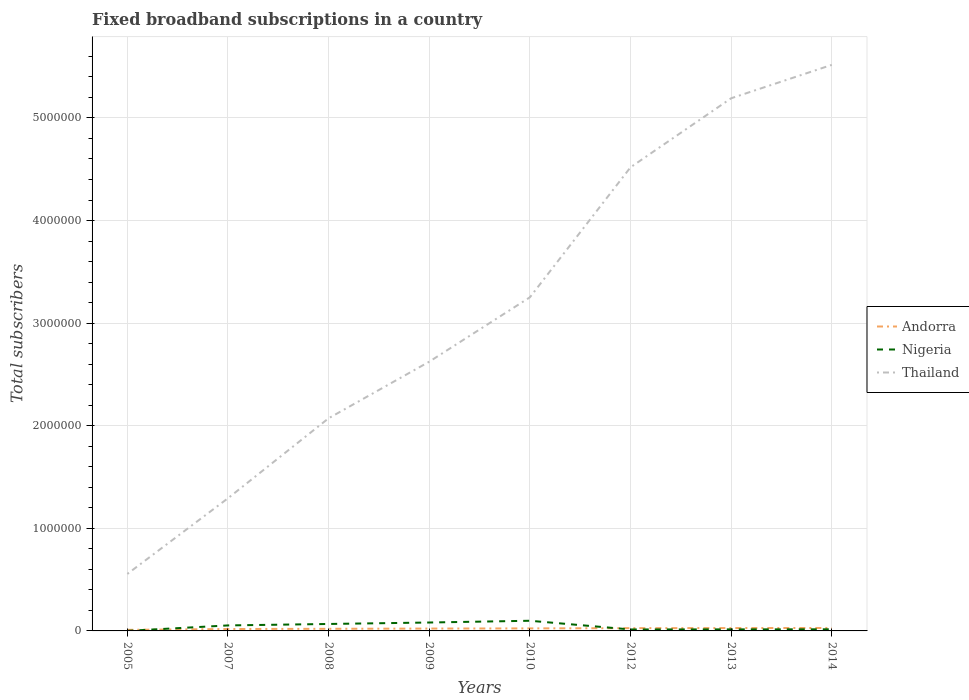Does the line corresponding to Thailand intersect with the line corresponding to Nigeria?
Your answer should be compact. No. Across all years, what is the maximum number of broadband subscriptions in Thailand?
Give a very brief answer. 5.55e+05. In which year was the number of broadband subscriptions in Thailand maximum?
Provide a succinct answer. 2005. What is the total number of broadband subscriptions in Andorra in the graph?
Make the answer very short. -5829. What is the difference between the highest and the second highest number of broadband subscriptions in Andorra?
Provide a succinct answer. 1.84e+04. Is the number of broadband subscriptions in Thailand strictly greater than the number of broadband subscriptions in Andorra over the years?
Give a very brief answer. No. What is the difference between two consecutive major ticks on the Y-axis?
Give a very brief answer. 1.00e+06. Where does the legend appear in the graph?
Ensure brevity in your answer.  Center right. How many legend labels are there?
Your answer should be compact. 3. How are the legend labels stacked?
Your answer should be very brief. Vertical. What is the title of the graph?
Provide a succinct answer. Fixed broadband subscriptions in a country. What is the label or title of the X-axis?
Give a very brief answer. Years. What is the label or title of the Y-axis?
Offer a terse response. Total subscribers. What is the Total subscribers in Andorra in 2005?
Provide a short and direct response. 1.03e+04. What is the Total subscribers in Thailand in 2005?
Give a very brief answer. 5.55e+05. What is the Total subscribers in Andorra in 2007?
Make the answer very short. 1.85e+04. What is the Total subscribers in Nigeria in 2007?
Your answer should be very brief. 5.36e+04. What is the Total subscribers of Thailand in 2007?
Your response must be concise. 1.29e+06. What is the Total subscribers of Andorra in 2008?
Offer a terse response. 2.07e+04. What is the Total subscribers of Nigeria in 2008?
Offer a terse response. 6.78e+04. What is the Total subscribers in Thailand in 2008?
Provide a short and direct response. 2.07e+06. What is the Total subscribers in Andorra in 2009?
Give a very brief answer. 2.29e+04. What is the Total subscribers in Nigeria in 2009?
Offer a terse response. 8.20e+04. What is the Total subscribers of Thailand in 2009?
Provide a short and direct response. 2.62e+06. What is the Total subscribers in Andorra in 2010?
Your response must be concise. 2.45e+04. What is the Total subscribers in Nigeria in 2010?
Provide a short and direct response. 9.91e+04. What is the Total subscribers of Thailand in 2010?
Your answer should be very brief. 3.25e+06. What is the Total subscribers of Andorra in 2012?
Offer a very short reply. 2.69e+04. What is the Total subscribers in Nigeria in 2012?
Offer a very short reply. 1.43e+04. What is the Total subscribers of Thailand in 2012?
Your response must be concise. 4.52e+06. What is the Total subscribers in Andorra in 2013?
Give a very brief answer. 2.77e+04. What is the Total subscribers in Nigeria in 2013?
Your answer should be very brief. 1.50e+04. What is the Total subscribers in Thailand in 2013?
Provide a succinct answer. 5.19e+06. What is the Total subscribers of Andorra in 2014?
Your answer should be very brief. 2.88e+04. What is the Total subscribers of Nigeria in 2014?
Make the answer very short. 1.57e+04. What is the Total subscribers of Thailand in 2014?
Provide a short and direct response. 5.52e+06. Across all years, what is the maximum Total subscribers in Andorra?
Give a very brief answer. 2.88e+04. Across all years, what is the maximum Total subscribers in Nigeria?
Give a very brief answer. 9.91e+04. Across all years, what is the maximum Total subscribers in Thailand?
Offer a very short reply. 5.52e+06. Across all years, what is the minimum Total subscribers of Andorra?
Your answer should be very brief. 1.03e+04. Across all years, what is the minimum Total subscribers in Nigeria?
Keep it short and to the point. 500. Across all years, what is the minimum Total subscribers of Thailand?
Your answer should be very brief. 5.55e+05. What is the total Total subscribers of Andorra in the graph?
Give a very brief answer. 1.80e+05. What is the total Total subscribers in Nigeria in the graph?
Give a very brief answer. 3.48e+05. What is the total Total subscribers of Thailand in the graph?
Offer a terse response. 2.50e+07. What is the difference between the Total subscribers of Andorra in 2005 and that in 2007?
Offer a very short reply. -8185. What is the difference between the Total subscribers in Nigeria in 2005 and that in 2007?
Make the answer very short. -5.31e+04. What is the difference between the Total subscribers in Thailand in 2005 and that in 2007?
Ensure brevity in your answer.  -7.38e+05. What is the difference between the Total subscribers of Andorra in 2005 and that in 2008?
Give a very brief answer. -1.03e+04. What is the difference between the Total subscribers in Nigeria in 2005 and that in 2008?
Make the answer very short. -6.73e+04. What is the difference between the Total subscribers of Thailand in 2005 and that in 2008?
Give a very brief answer. -1.52e+06. What is the difference between the Total subscribers of Andorra in 2005 and that in 2009?
Offer a very short reply. -1.26e+04. What is the difference between the Total subscribers of Nigeria in 2005 and that in 2009?
Ensure brevity in your answer.  -8.15e+04. What is the difference between the Total subscribers of Thailand in 2005 and that in 2009?
Offer a very short reply. -2.07e+06. What is the difference between the Total subscribers of Andorra in 2005 and that in 2010?
Offer a very short reply. -1.42e+04. What is the difference between the Total subscribers of Nigeria in 2005 and that in 2010?
Provide a succinct answer. -9.86e+04. What is the difference between the Total subscribers in Thailand in 2005 and that in 2010?
Make the answer very short. -2.70e+06. What is the difference between the Total subscribers in Andorra in 2005 and that in 2012?
Give a very brief answer. -1.66e+04. What is the difference between the Total subscribers of Nigeria in 2005 and that in 2012?
Your answer should be compact. -1.38e+04. What is the difference between the Total subscribers of Thailand in 2005 and that in 2012?
Provide a short and direct response. -3.96e+06. What is the difference between the Total subscribers of Andorra in 2005 and that in 2013?
Give a very brief answer. -1.74e+04. What is the difference between the Total subscribers in Nigeria in 2005 and that in 2013?
Your answer should be compact. -1.45e+04. What is the difference between the Total subscribers in Thailand in 2005 and that in 2013?
Offer a terse response. -4.64e+06. What is the difference between the Total subscribers of Andorra in 2005 and that in 2014?
Your answer should be very brief. -1.84e+04. What is the difference between the Total subscribers in Nigeria in 2005 and that in 2014?
Keep it short and to the point. -1.52e+04. What is the difference between the Total subscribers in Thailand in 2005 and that in 2014?
Offer a terse response. -4.96e+06. What is the difference between the Total subscribers of Andorra in 2007 and that in 2008?
Offer a terse response. -2146. What is the difference between the Total subscribers of Nigeria in 2007 and that in 2008?
Your answer should be very brief. -1.42e+04. What is the difference between the Total subscribers in Thailand in 2007 and that in 2008?
Offer a very short reply. -7.79e+05. What is the difference between the Total subscribers of Andorra in 2007 and that in 2009?
Your answer should be very brief. -4415. What is the difference between the Total subscribers in Nigeria in 2007 and that in 2009?
Provide a succinct answer. -2.84e+04. What is the difference between the Total subscribers in Thailand in 2007 and that in 2009?
Your answer should be very brief. -1.33e+06. What is the difference between the Total subscribers of Andorra in 2007 and that in 2010?
Offer a terse response. -5976. What is the difference between the Total subscribers of Nigeria in 2007 and that in 2010?
Provide a succinct answer. -4.55e+04. What is the difference between the Total subscribers of Thailand in 2007 and that in 2010?
Make the answer very short. -1.96e+06. What is the difference between the Total subscribers of Andorra in 2007 and that in 2012?
Keep it short and to the point. -8379. What is the difference between the Total subscribers of Nigeria in 2007 and that in 2012?
Your answer should be very brief. 3.93e+04. What is the difference between the Total subscribers in Thailand in 2007 and that in 2012?
Keep it short and to the point. -3.23e+06. What is the difference between the Total subscribers of Andorra in 2007 and that in 2013?
Make the answer very short. -9208. What is the difference between the Total subscribers of Nigeria in 2007 and that in 2013?
Offer a very short reply. 3.85e+04. What is the difference between the Total subscribers in Thailand in 2007 and that in 2013?
Your response must be concise. -3.90e+06. What is the difference between the Total subscribers in Andorra in 2007 and that in 2014?
Make the answer very short. -1.02e+04. What is the difference between the Total subscribers of Nigeria in 2007 and that in 2014?
Provide a succinct answer. 3.79e+04. What is the difference between the Total subscribers in Thailand in 2007 and that in 2014?
Ensure brevity in your answer.  -4.22e+06. What is the difference between the Total subscribers in Andorra in 2008 and that in 2009?
Your response must be concise. -2269. What is the difference between the Total subscribers in Nigeria in 2008 and that in 2009?
Offer a terse response. -1.42e+04. What is the difference between the Total subscribers of Thailand in 2008 and that in 2009?
Your response must be concise. -5.51e+05. What is the difference between the Total subscribers of Andorra in 2008 and that in 2010?
Keep it short and to the point. -3830. What is the difference between the Total subscribers in Nigeria in 2008 and that in 2010?
Ensure brevity in your answer.  -3.13e+04. What is the difference between the Total subscribers in Thailand in 2008 and that in 2010?
Your response must be concise. -1.18e+06. What is the difference between the Total subscribers in Andorra in 2008 and that in 2012?
Offer a very short reply. -6233. What is the difference between the Total subscribers in Nigeria in 2008 and that in 2012?
Give a very brief answer. 5.35e+04. What is the difference between the Total subscribers of Thailand in 2008 and that in 2012?
Offer a terse response. -2.45e+06. What is the difference between the Total subscribers in Andorra in 2008 and that in 2013?
Your response must be concise. -7062. What is the difference between the Total subscribers in Nigeria in 2008 and that in 2013?
Your response must be concise. 5.27e+04. What is the difference between the Total subscribers of Thailand in 2008 and that in 2013?
Give a very brief answer. -3.12e+06. What is the difference between the Total subscribers of Andorra in 2008 and that in 2014?
Keep it short and to the point. -8098. What is the difference between the Total subscribers in Nigeria in 2008 and that in 2014?
Your response must be concise. 5.20e+04. What is the difference between the Total subscribers of Thailand in 2008 and that in 2014?
Make the answer very short. -3.44e+06. What is the difference between the Total subscribers in Andorra in 2009 and that in 2010?
Your answer should be compact. -1561. What is the difference between the Total subscribers of Nigeria in 2009 and that in 2010?
Keep it short and to the point. -1.72e+04. What is the difference between the Total subscribers of Thailand in 2009 and that in 2010?
Ensure brevity in your answer.  -6.28e+05. What is the difference between the Total subscribers of Andorra in 2009 and that in 2012?
Keep it short and to the point. -3964. What is the difference between the Total subscribers of Nigeria in 2009 and that in 2012?
Your answer should be compact. 6.77e+04. What is the difference between the Total subscribers in Thailand in 2009 and that in 2012?
Give a very brief answer. -1.89e+06. What is the difference between the Total subscribers in Andorra in 2009 and that in 2013?
Offer a very short reply. -4793. What is the difference between the Total subscribers in Nigeria in 2009 and that in 2013?
Your answer should be very brief. 6.69e+04. What is the difference between the Total subscribers of Thailand in 2009 and that in 2013?
Provide a succinct answer. -2.57e+06. What is the difference between the Total subscribers of Andorra in 2009 and that in 2014?
Give a very brief answer. -5829. What is the difference between the Total subscribers in Nigeria in 2009 and that in 2014?
Make the answer very short. 6.62e+04. What is the difference between the Total subscribers in Thailand in 2009 and that in 2014?
Your answer should be very brief. -2.89e+06. What is the difference between the Total subscribers in Andorra in 2010 and that in 2012?
Your answer should be very brief. -2403. What is the difference between the Total subscribers of Nigeria in 2010 and that in 2012?
Your answer should be compact. 8.48e+04. What is the difference between the Total subscribers of Thailand in 2010 and that in 2012?
Your answer should be very brief. -1.27e+06. What is the difference between the Total subscribers of Andorra in 2010 and that in 2013?
Provide a succinct answer. -3232. What is the difference between the Total subscribers of Nigeria in 2010 and that in 2013?
Offer a terse response. 8.41e+04. What is the difference between the Total subscribers in Thailand in 2010 and that in 2013?
Provide a succinct answer. -1.94e+06. What is the difference between the Total subscribers in Andorra in 2010 and that in 2014?
Ensure brevity in your answer.  -4268. What is the difference between the Total subscribers in Nigeria in 2010 and that in 2014?
Offer a terse response. 8.34e+04. What is the difference between the Total subscribers of Thailand in 2010 and that in 2014?
Keep it short and to the point. -2.27e+06. What is the difference between the Total subscribers of Andorra in 2012 and that in 2013?
Your response must be concise. -829. What is the difference between the Total subscribers in Nigeria in 2012 and that in 2013?
Keep it short and to the point. -766. What is the difference between the Total subscribers in Thailand in 2012 and that in 2013?
Give a very brief answer. -6.73e+05. What is the difference between the Total subscribers of Andorra in 2012 and that in 2014?
Your response must be concise. -1865. What is the difference between the Total subscribers of Nigeria in 2012 and that in 2014?
Offer a terse response. -1461. What is the difference between the Total subscribers of Thailand in 2012 and that in 2014?
Your response must be concise. -9.98e+05. What is the difference between the Total subscribers of Andorra in 2013 and that in 2014?
Your response must be concise. -1036. What is the difference between the Total subscribers in Nigeria in 2013 and that in 2014?
Provide a succinct answer. -695. What is the difference between the Total subscribers of Thailand in 2013 and that in 2014?
Your response must be concise. -3.25e+05. What is the difference between the Total subscribers in Andorra in 2005 and the Total subscribers in Nigeria in 2007?
Your answer should be very brief. -4.33e+04. What is the difference between the Total subscribers of Andorra in 2005 and the Total subscribers of Thailand in 2007?
Provide a succinct answer. -1.28e+06. What is the difference between the Total subscribers of Nigeria in 2005 and the Total subscribers of Thailand in 2007?
Your answer should be compact. -1.29e+06. What is the difference between the Total subscribers in Andorra in 2005 and the Total subscribers in Nigeria in 2008?
Your answer should be very brief. -5.74e+04. What is the difference between the Total subscribers of Andorra in 2005 and the Total subscribers of Thailand in 2008?
Your answer should be very brief. -2.06e+06. What is the difference between the Total subscribers in Nigeria in 2005 and the Total subscribers in Thailand in 2008?
Give a very brief answer. -2.07e+06. What is the difference between the Total subscribers of Andorra in 2005 and the Total subscribers of Nigeria in 2009?
Offer a terse response. -7.16e+04. What is the difference between the Total subscribers of Andorra in 2005 and the Total subscribers of Thailand in 2009?
Offer a terse response. -2.61e+06. What is the difference between the Total subscribers of Nigeria in 2005 and the Total subscribers of Thailand in 2009?
Your answer should be very brief. -2.62e+06. What is the difference between the Total subscribers of Andorra in 2005 and the Total subscribers of Nigeria in 2010?
Give a very brief answer. -8.88e+04. What is the difference between the Total subscribers of Andorra in 2005 and the Total subscribers of Thailand in 2010?
Offer a very short reply. -3.24e+06. What is the difference between the Total subscribers in Nigeria in 2005 and the Total subscribers in Thailand in 2010?
Offer a very short reply. -3.25e+06. What is the difference between the Total subscribers in Andorra in 2005 and the Total subscribers in Nigeria in 2012?
Give a very brief answer. -3938. What is the difference between the Total subscribers of Andorra in 2005 and the Total subscribers of Thailand in 2012?
Offer a very short reply. -4.51e+06. What is the difference between the Total subscribers in Nigeria in 2005 and the Total subscribers in Thailand in 2012?
Your answer should be compact. -4.52e+06. What is the difference between the Total subscribers of Andorra in 2005 and the Total subscribers of Nigeria in 2013?
Your answer should be compact. -4704. What is the difference between the Total subscribers of Andorra in 2005 and the Total subscribers of Thailand in 2013?
Keep it short and to the point. -5.18e+06. What is the difference between the Total subscribers in Nigeria in 2005 and the Total subscribers in Thailand in 2013?
Your response must be concise. -5.19e+06. What is the difference between the Total subscribers in Andorra in 2005 and the Total subscribers in Nigeria in 2014?
Keep it short and to the point. -5399. What is the difference between the Total subscribers of Andorra in 2005 and the Total subscribers of Thailand in 2014?
Offer a terse response. -5.51e+06. What is the difference between the Total subscribers in Nigeria in 2005 and the Total subscribers in Thailand in 2014?
Your answer should be very brief. -5.52e+06. What is the difference between the Total subscribers in Andorra in 2007 and the Total subscribers in Nigeria in 2008?
Provide a short and direct response. -4.92e+04. What is the difference between the Total subscribers in Andorra in 2007 and the Total subscribers in Thailand in 2008?
Your answer should be very brief. -2.05e+06. What is the difference between the Total subscribers in Nigeria in 2007 and the Total subscribers in Thailand in 2008?
Make the answer very short. -2.02e+06. What is the difference between the Total subscribers of Andorra in 2007 and the Total subscribers of Nigeria in 2009?
Your response must be concise. -6.34e+04. What is the difference between the Total subscribers in Andorra in 2007 and the Total subscribers in Thailand in 2009?
Make the answer very short. -2.61e+06. What is the difference between the Total subscribers in Nigeria in 2007 and the Total subscribers in Thailand in 2009?
Provide a succinct answer. -2.57e+06. What is the difference between the Total subscribers of Andorra in 2007 and the Total subscribers of Nigeria in 2010?
Offer a very short reply. -8.06e+04. What is the difference between the Total subscribers in Andorra in 2007 and the Total subscribers in Thailand in 2010?
Your answer should be compact. -3.23e+06. What is the difference between the Total subscribers of Nigeria in 2007 and the Total subscribers of Thailand in 2010?
Your answer should be compact. -3.20e+06. What is the difference between the Total subscribers in Andorra in 2007 and the Total subscribers in Nigeria in 2012?
Offer a very short reply. 4247. What is the difference between the Total subscribers in Andorra in 2007 and the Total subscribers in Thailand in 2012?
Your answer should be compact. -4.50e+06. What is the difference between the Total subscribers of Nigeria in 2007 and the Total subscribers of Thailand in 2012?
Provide a succinct answer. -4.47e+06. What is the difference between the Total subscribers of Andorra in 2007 and the Total subscribers of Nigeria in 2013?
Keep it short and to the point. 3481. What is the difference between the Total subscribers of Andorra in 2007 and the Total subscribers of Thailand in 2013?
Offer a terse response. -5.17e+06. What is the difference between the Total subscribers of Nigeria in 2007 and the Total subscribers of Thailand in 2013?
Provide a succinct answer. -5.14e+06. What is the difference between the Total subscribers in Andorra in 2007 and the Total subscribers in Nigeria in 2014?
Your answer should be compact. 2786. What is the difference between the Total subscribers in Andorra in 2007 and the Total subscribers in Thailand in 2014?
Offer a terse response. -5.50e+06. What is the difference between the Total subscribers in Nigeria in 2007 and the Total subscribers in Thailand in 2014?
Ensure brevity in your answer.  -5.46e+06. What is the difference between the Total subscribers of Andorra in 2008 and the Total subscribers of Nigeria in 2009?
Offer a terse response. -6.13e+04. What is the difference between the Total subscribers of Andorra in 2008 and the Total subscribers of Thailand in 2009?
Offer a very short reply. -2.60e+06. What is the difference between the Total subscribers in Nigeria in 2008 and the Total subscribers in Thailand in 2009?
Offer a very short reply. -2.56e+06. What is the difference between the Total subscribers of Andorra in 2008 and the Total subscribers of Nigeria in 2010?
Make the answer very short. -7.84e+04. What is the difference between the Total subscribers of Andorra in 2008 and the Total subscribers of Thailand in 2010?
Ensure brevity in your answer.  -3.23e+06. What is the difference between the Total subscribers in Nigeria in 2008 and the Total subscribers in Thailand in 2010?
Provide a short and direct response. -3.18e+06. What is the difference between the Total subscribers in Andorra in 2008 and the Total subscribers in Nigeria in 2012?
Keep it short and to the point. 6393. What is the difference between the Total subscribers of Andorra in 2008 and the Total subscribers of Thailand in 2012?
Offer a terse response. -4.50e+06. What is the difference between the Total subscribers in Nigeria in 2008 and the Total subscribers in Thailand in 2012?
Give a very brief answer. -4.45e+06. What is the difference between the Total subscribers in Andorra in 2008 and the Total subscribers in Nigeria in 2013?
Give a very brief answer. 5627. What is the difference between the Total subscribers in Andorra in 2008 and the Total subscribers in Thailand in 2013?
Give a very brief answer. -5.17e+06. What is the difference between the Total subscribers in Nigeria in 2008 and the Total subscribers in Thailand in 2013?
Provide a short and direct response. -5.12e+06. What is the difference between the Total subscribers in Andorra in 2008 and the Total subscribers in Nigeria in 2014?
Your answer should be compact. 4932. What is the difference between the Total subscribers in Andorra in 2008 and the Total subscribers in Thailand in 2014?
Provide a short and direct response. -5.50e+06. What is the difference between the Total subscribers of Nigeria in 2008 and the Total subscribers of Thailand in 2014?
Your response must be concise. -5.45e+06. What is the difference between the Total subscribers in Andorra in 2009 and the Total subscribers in Nigeria in 2010?
Give a very brief answer. -7.62e+04. What is the difference between the Total subscribers of Andorra in 2009 and the Total subscribers of Thailand in 2010?
Provide a short and direct response. -3.23e+06. What is the difference between the Total subscribers of Nigeria in 2009 and the Total subscribers of Thailand in 2010?
Offer a terse response. -3.17e+06. What is the difference between the Total subscribers in Andorra in 2009 and the Total subscribers in Nigeria in 2012?
Provide a succinct answer. 8662. What is the difference between the Total subscribers of Andorra in 2009 and the Total subscribers of Thailand in 2012?
Offer a terse response. -4.50e+06. What is the difference between the Total subscribers of Nigeria in 2009 and the Total subscribers of Thailand in 2012?
Give a very brief answer. -4.44e+06. What is the difference between the Total subscribers of Andorra in 2009 and the Total subscribers of Nigeria in 2013?
Give a very brief answer. 7896. What is the difference between the Total subscribers of Andorra in 2009 and the Total subscribers of Thailand in 2013?
Make the answer very short. -5.17e+06. What is the difference between the Total subscribers in Nigeria in 2009 and the Total subscribers in Thailand in 2013?
Give a very brief answer. -5.11e+06. What is the difference between the Total subscribers in Andorra in 2009 and the Total subscribers in Nigeria in 2014?
Offer a very short reply. 7201. What is the difference between the Total subscribers in Andorra in 2009 and the Total subscribers in Thailand in 2014?
Make the answer very short. -5.49e+06. What is the difference between the Total subscribers of Nigeria in 2009 and the Total subscribers of Thailand in 2014?
Your answer should be compact. -5.44e+06. What is the difference between the Total subscribers in Andorra in 2010 and the Total subscribers in Nigeria in 2012?
Keep it short and to the point. 1.02e+04. What is the difference between the Total subscribers of Andorra in 2010 and the Total subscribers of Thailand in 2012?
Make the answer very short. -4.49e+06. What is the difference between the Total subscribers of Nigeria in 2010 and the Total subscribers of Thailand in 2012?
Your answer should be compact. -4.42e+06. What is the difference between the Total subscribers of Andorra in 2010 and the Total subscribers of Nigeria in 2013?
Offer a very short reply. 9457. What is the difference between the Total subscribers in Andorra in 2010 and the Total subscribers in Thailand in 2013?
Provide a succinct answer. -5.17e+06. What is the difference between the Total subscribers in Nigeria in 2010 and the Total subscribers in Thailand in 2013?
Provide a succinct answer. -5.09e+06. What is the difference between the Total subscribers in Andorra in 2010 and the Total subscribers in Nigeria in 2014?
Provide a succinct answer. 8762. What is the difference between the Total subscribers of Andorra in 2010 and the Total subscribers of Thailand in 2014?
Offer a very short reply. -5.49e+06. What is the difference between the Total subscribers in Nigeria in 2010 and the Total subscribers in Thailand in 2014?
Your answer should be very brief. -5.42e+06. What is the difference between the Total subscribers in Andorra in 2012 and the Total subscribers in Nigeria in 2013?
Offer a terse response. 1.19e+04. What is the difference between the Total subscribers of Andorra in 2012 and the Total subscribers of Thailand in 2013?
Provide a succinct answer. -5.17e+06. What is the difference between the Total subscribers in Nigeria in 2012 and the Total subscribers in Thailand in 2013?
Provide a succinct answer. -5.18e+06. What is the difference between the Total subscribers of Andorra in 2012 and the Total subscribers of Nigeria in 2014?
Ensure brevity in your answer.  1.12e+04. What is the difference between the Total subscribers in Andorra in 2012 and the Total subscribers in Thailand in 2014?
Keep it short and to the point. -5.49e+06. What is the difference between the Total subscribers of Nigeria in 2012 and the Total subscribers of Thailand in 2014?
Offer a terse response. -5.50e+06. What is the difference between the Total subscribers of Andorra in 2013 and the Total subscribers of Nigeria in 2014?
Provide a succinct answer. 1.20e+04. What is the difference between the Total subscribers of Andorra in 2013 and the Total subscribers of Thailand in 2014?
Offer a very short reply. -5.49e+06. What is the difference between the Total subscribers in Nigeria in 2013 and the Total subscribers in Thailand in 2014?
Offer a very short reply. -5.50e+06. What is the average Total subscribers in Andorra per year?
Make the answer very short. 2.25e+04. What is the average Total subscribers of Nigeria per year?
Make the answer very short. 4.35e+04. What is the average Total subscribers in Thailand per year?
Your answer should be very brief. 3.13e+06. In the year 2005, what is the difference between the Total subscribers in Andorra and Total subscribers in Nigeria?
Your answer should be compact. 9841. In the year 2005, what is the difference between the Total subscribers in Andorra and Total subscribers in Thailand?
Your answer should be very brief. -5.45e+05. In the year 2005, what is the difference between the Total subscribers in Nigeria and Total subscribers in Thailand?
Offer a terse response. -5.55e+05. In the year 2007, what is the difference between the Total subscribers of Andorra and Total subscribers of Nigeria?
Ensure brevity in your answer.  -3.51e+04. In the year 2007, what is the difference between the Total subscribers of Andorra and Total subscribers of Thailand?
Make the answer very short. -1.27e+06. In the year 2007, what is the difference between the Total subscribers in Nigeria and Total subscribers in Thailand?
Offer a very short reply. -1.24e+06. In the year 2008, what is the difference between the Total subscribers of Andorra and Total subscribers of Nigeria?
Your answer should be compact. -4.71e+04. In the year 2008, what is the difference between the Total subscribers in Andorra and Total subscribers in Thailand?
Provide a succinct answer. -2.05e+06. In the year 2008, what is the difference between the Total subscribers of Nigeria and Total subscribers of Thailand?
Offer a very short reply. -2.01e+06. In the year 2009, what is the difference between the Total subscribers of Andorra and Total subscribers of Nigeria?
Keep it short and to the point. -5.90e+04. In the year 2009, what is the difference between the Total subscribers of Andorra and Total subscribers of Thailand?
Keep it short and to the point. -2.60e+06. In the year 2009, what is the difference between the Total subscribers in Nigeria and Total subscribers in Thailand?
Keep it short and to the point. -2.54e+06. In the year 2010, what is the difference between the Total subscribers of Andorra and Total subscribers of Nigeria?
Your answer should be very brief. -7.46e+04. In the year 2010, what is the difference between the Total subscribers in Andorra and Total subscribers in Thailand?
Provide a succinct answer. -3.23e+06. In the year 2010, what is the difference between the Total subscribers in Nigeria and Total subscribers in Thailand?
Make the answer very short. -3.15e+06. In the year 2012, what is the difference between the Total subscribers in Andorra and Total subscribers in Nigeria?
Provide a succinct answer. 1.26e+04. In the year 2012, what is the difference between the Total subscribers in Andorra and Total subscribers in Thailand?
Keep it short and to the point. -4.49e+06. In the year 2012, what is the difference between the Total subscribers in Nigeria and Total subscribers in Thailand?
Give a very brief answer. -4.50e+06. In the year 2013, what is the difference between the Total subscribers in Andorra and Total subscribers in Nigeria?
Keep it short and to the point. 1.27e+04. In the year 2013, what is the difference between the Total subscribers of Andorra and Total subscribers of Thailand?
Keep it short and to the point. -5.16e+06. In the year 2013, what is the difference between the Total subscribers of Nigeria and Total subscribers of Thailand?
Your answer should be very brief. -5.18e+06. In the year 2014, what is the difference between the Total subscribers in Andorra and Total subscribers in Nigeria?
Offer a terse response. 1.30e+04. In the year 2014, what is the difference between the Total subscribers in Andorra and Total subscribers in Thailand?
Offer a terse response. -5.49e+06. In the year 2014, what is the difference between the Total subscribers of Nigeria and Total subscribers of Thailand?
Offer a very short reply. -5.50e+06. What is the ratio of the Total subscribers in Andorra in 2005 to that in 2007?
Provide a short and direct response. 0.56. What is the ratio of the Total subscribers of Nigeria in 2005 to that in 2007?
Provide a short and direct response. 0.01. What is the ratio of the Total subscribers of Thailand in 2005 to that in 2007?
Provide a succinct answer. 0.43. What is the ratio of the Total subscribers in Andorra in 2005 to that in 2008?
Your answer should be compact. 0.5. What is the ratio of the Total subscribers of Nigeria in 2005 to that in 2008?
Ensure brevity in your answer.  0.01. What is the ratio of the Total subscribers of Thailand in 2005 to that in 2008?
Keep it short and to the point. 0.27. What is the ratio of the Total subscribers of Andorra in 2005 to that in 2009?
Provide a succinct answer. 0.45. What is the ratio of the Total subscribers of Nigeria in 2005 to that in 2009?
Your answer should be compact. 0.01. What is the ratio of the Total subscribers of Thailand in 2005 to that in 2009?
Give a very brief answer. 0.21. What is the ratio of the Total subscribers of Andorra in 2005 to that in 2010?
Keep it short and to the point. 0.42. What is the ratio of the Total subscribers of Nigeria in 2005 to that in 2010?
Give a very brief answer. 0.01. What is the ratio of the Total subscribers in Thailand in 2005 to that in 2010?
Offer a very short reply. 0.17. What is the ratio of the Total subscribers of Andorra in 2005 to that in 2012?
Ensure brevity in your answer.  0.38. What is the ratio of the Total subscribers in Nigeria in 2005 to that in 2012?
Offer a terse response. 0.04. What is the ratio of the Total subscribers of Thailand in 2005 to that in 2012?
Keep it short and to the point. 0.12. What is the ratio of the Total subscribers in Andorra in 2005 to that in 2013?
Keep it short and to the point. 0.37. What is the ratio of the Total subscribers in Nigeria in 2005 to that in 2013?
Offer a terse response. 0.03. What is the ratio of the Total subscribers in Thailand in 2005 to that in 2013?
Your response must be concise. 0.11. What is the ratio of the Total subscribers of Andorra in 2005 to that in 2014?
Keep it short and to the point. 0.36. What is the ratio of the Total subscribers of Nigeria in 2005 to that in 2014?
Your response must be concise. 0.03. What is the ratio of the Total subscribers of Thailand in 2005 to that in 2014?
Provide a succinct answer. 0.1. What is the ratio of the Total subscribers in Andorra in 2007 to that in 2008?
Provide a short and direct response. 0.9. What is the ratio of the Total subscribers in Nigeria in 2007 to that in 2008?
Keep it short and to the point. 0.79. What is the ratio of the Total subscribers of Thailand in 2007 to that in 2008?
Keep it short and to the point. 0.62. What is the ratio of the Total subscribers of Andorra in 2007 to that in 2009?
Your response must be concise. 0.81. What is the ratio of the Total subscribers of Nigeria in 2007 to that in 2009?
Provide a succinct answer. 0.65. What is the ratio of the Total subscribers of Thailand in 2007 to that in 2009?
Ensure brevity in your answer.  0.49. What is the ratio of the Total subscribers of Andorra in 2007 to that in 2010?
Offer a very short reply. 0.76. What is the ratio of the Total subscribers in Nigeria in 2007 to that in 2010?
Your answer should be very brief. 0.54. What is the ratio of the Total subscribers of Thailand in 2007 to that in 2010?
Offer a very short reply. 0.4. What is the ratio of the Total subscribers in Andorra in 2007 to that in 2012?
Keep it short and to the point. 0.69. What is the ratio of the Total subscribers of Nigeria in 2007 to that in 2012?
Your answer should be very brief. 3.75. What is the ratio of the Total subscribers in Thailand in 2007 to that in 2012?
Ensure brevity in your answer.  0.29. What is the ratio of the Total subscribers of Andorra in 2007 to that in 2013?
Your answer should be compact. 0.67. What is the ratio of the Total subscribers in Nigeria in 2007 to that in 2013?
Provide a short and direct response. 3.56. What is the ratio of the Total subscribers of Thailand in 2007 to that in 2013?
Make the answer very short. 0.25. What is the ratio of the Total subscribers of Andorra in 2007 to that in 2014?
Offer a terse response. 0.64. What is the ratio of the Total subscribers in Nigeria in 2007 to that in 2014?
Your response must be concise. 3.4. What is the ratio of the Total subscribers in Thailand in 2007 to that in 2014?
Offer a terse response. 0.23. What is the ratio of the Total subscribers in Andorra in 2008 to that in 2009?
Your response must be concise. 0.9. What is the ratio of the Total subscribers in Nigeria in 2008 to that in 2009?
Keep it short and to the point. 0.83. What is the ratio of the Total subscribers in Thailand in 2008 to that in 2009?
Provide a succinct answer. 0.79. What is the ratio of the Total subscribers of Andorra in 2008 to that in 2010?
Offer a very short reply. 0.84. What is the ratio of the Total subscribers in Nigeria in 2008 to that in 2010?
Offer a very short reply. 0.68. What is the ratio of the Total subscribers in Thailand in 2008 to that in 2010?
Ensure brevity in your answer.  0.64. What is the ratio of the Total subscribers of Andorra in 2008 to that in 2012?
Your answer should be very brief. 0.77. What is the ratio of the Total subscribers of Nigeria in 2008 to that in 2012?
Make the answer very short. 4.75. What is the ratio of the Total subscribers in Thailand in 2008 to that in 2012?
Your answer should be very brief. 0.46. What is the ratio of the Total subscribers of Andorra in 2008 to that in 2013?
Offer a terse response. 0.75. What is the ratio of the Total subscribers of Nigeria in 2008 to that in 2013?
Provide a succinct answer. 4.5. What is the ratio of the Total subscribers in Thailand in 2008 to that in 2013?
Ensure brevity in your answer.  0.4. What is the ratio of the Total subscribers of Andorra in 2008 to that in 2014?
Ensure brevity in your answer.  0.72. What is the ratio of the Total subscribers in Nigeria in 2008 to that in 2014?
Provide a succinct answer. 4.31. What is the ratio of the Total subscribers in Thailand in 2008 to that in 2014?
Ensure brevity in your answer.  0.38. What is the ratio of the Total subscribers in Andorra in 2009 to that in 2010?
Provide a succinct answer. 0.94. What is the ratio of the Total subscribers of Nigeria in 2009 to that in 2010?
Your answer should be very brief. 0.83. What is the ratio of the Total subscribers of Thailand in 2009 to that in 2010?
Your response must be concise. 0.81. What is the ratio of the Total subscribers in Andorra in 2009 to that in 2012?
Provide a short and direct response. 0.85. What is the ratio of the Total subscribers of Nigeria in 2009 to that in 2012?
Provide a short and direct response. 5.74. What is the ratio of the Total subscribers in Thailand in 2009 to that in 2012?
Provide a short and direct response. 0.58. What is the ratio of the Total subscribers of Andorra in 2009 to that in 2013?
Make the answer very short. 0.83. What is the ratio of the Total subscribers of Nigeria in 2009 to that in 2013?
Give a very brief answer. 5.45. What is the ratio of the Total subscribers in Thailand in 2009 to that in 2013?
Provide a short and direct response. 0.51. What is the ratio of the Total subscribers in Andorra in 2009 to that in 2014?
Ensure brevity in your answer.  0.8. What is the ratio of the Total subscribers in Nigeria in 2009 to that in 2014?
Your response must be concise. 5.21. What is the ratio of the Total subscribers of Thailand in 2009 to that in 2014?
Ensure brevity in your answer.  0.48. What is the ratio of the Total subscribers in Andorra in 2010 to that in 2012?
Give a very brief answer. 0.91. What is the ratio of the Total subscribers of Nigeria in 2010 to that in 2012?
Provide a succinct answer. 6.94. What is the ratio of the Total subscribers of Thailand in 2010 to that in 2012?
Offer a terse response. 0.72. What is the ratio of the Total subscribers in Andorra in 2010 to that in 2013?
Make the answer very short. 0.88. What is the ratio of the Total subscribers of Nigeria in 2010 to that in 2013?
Your response must be concise. 6.59. What is the ratio of the Total subscribers of Thailand in 2010 to that in 2013?
Your answer should be very brief. 0.63. What is the ratio of the Total subscribers of Andorra in 2010 to that in 2014?
Provide a short and direct response. 0.85. What is the ratio of the Total subscribers of Nigeria in 2010 to that in 2014?
Give a very brief answer. 6.3. What is the ratio of the Total subscribers in Thailand in 2010 to that in 2014?
Offer a very short reply. 0.59. What is the ratio of the Total subscribers of Andorra in 2012 to that in 2013?
Your answer should be very brief. 0.97. What is the ratio of the Total subscribers of Nigeria in 2012 to that in 2013?
Offer a terse response. 0.95. What is the ratio of the Total subscribers in Thailand in 2012 to that in 2013?
Make the answer very short. 0.87. What is the ratio of the Total subscribers of Andorra in 2012 to that in 2014?
Offer a terse response. 0.94. What is the ratio of the Total subscribers in Nigeria in 2012 to that in 2014?
Your response must be concise. 0.91. What is the ratio of the Total subscribers in Thailand in 2012 to that in 2014?
Keep it short and to the point. 0.82. What is the ratio of the Total subscribers of Andorra in 2013 to that in 2014?
Keep it short and to the point. 0.96. What is the ratio of the Total subscribers in Nigeria in 2013 to that in 2014?
Offer a very short reply. 0.96. What is the ratio of the Total subscribers in Thailand in 2013 to that in 2014?
Provide a succinct answer. 0.94. What is the difference between the highest and the second highest Total subscribers in Andorra?
Your response must be concise. 1036. What is the difference between the highest and the second highest Total subscribers in Nigeria?
Provide a short and direct response. 1.72e+04. What is the difference between the highest and the second highest Total subscribers in Thailand?
Your answer should be very brief. 3.25e+05. What is the difference between the highest and the lowest Total subscribers in Andorra?
Make the answer very short. 1.84e+04. What is the difference between the highest and the lowest Total subscribers in Nigeria?
Offer a terse response. 9.86e+04. What is the difference between the highest and the lowest Total subscribers of Thailand?
Give a very brief answer. 4.96e+06. 